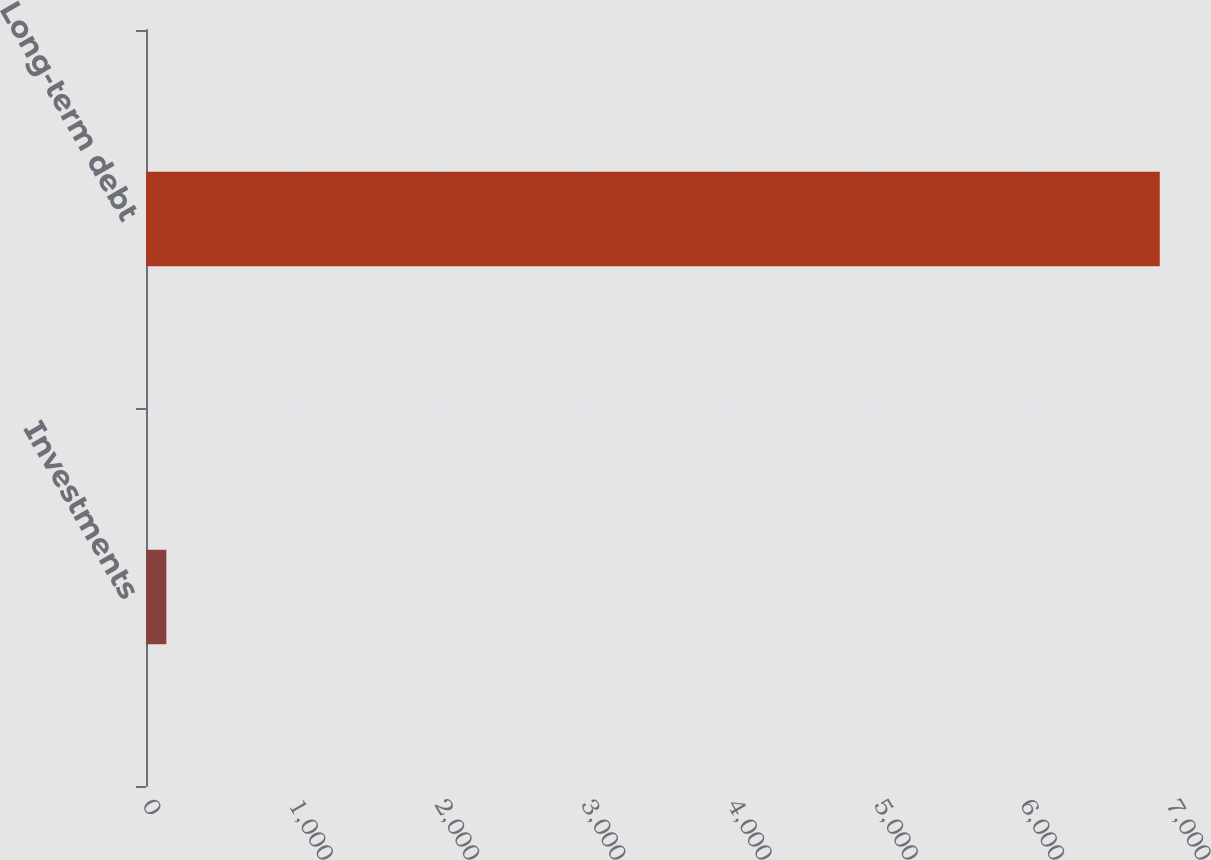<chart> <loc_0><loc_0><loc_500><loc_500><bar_chart><fcel>Investments<fcel>Long-term debt<nl><fcel>139<fcel>6930<nl></chart> 